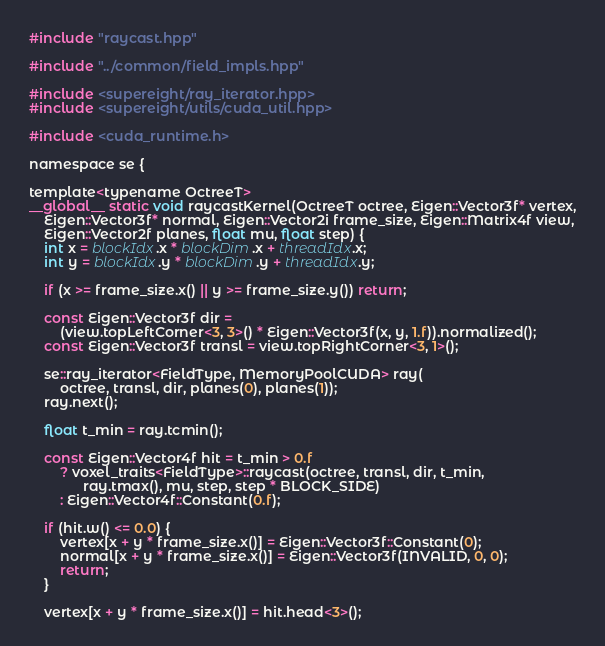Convert code to text. <code><loc_0><loc_0><loc_500><loc_500><_Cuda_>#include "raycast.hpp"

#include "../common/field_impls.hpp"

#include <supereight/ray_iterator.hpp>
#include <supereight/utils/cuda_util.hpp>

#include <cuda_runtime.h>

namespace se {

template<typename OctreeT>
__global__ static void raycastKernel(OctreeT octree, Eigen::Vector3f* vertex,
    Eigen::Vector3f* normal, Eigen::Vector2i frame_size, Eigen::Matrix4f view,
    Eigen::Vector2f planes, float mu, float step) {
    int x = blockIdx.x * blockDim.x + threadIdx.x;
    int y = blockIdx.y * blockDim.y + threadIdx.y;

    if (x >= frame_size.x() || y >= frame_size.y()) return;

    const Eigen::Vector3f dir =
        (view.topLeftCorner<3, 3>() * Eigen::Vector3f(x, y, 1.f)).normalized();
    const Eigen::Vector3f transl = view.topRightCorner<3, 1>();

    se::ray_iterator<FieldType, MemoryPoolCUDA> ray(
        octree, transl, dir, planes(0), planes(1));
    ray.next();

    float t_min = ray.tcmin();

    const Eigen::Vector4f hit = t_min > 0.f
        ? voxel_traits<FieldType>::raycast(octree, transl, dir, t_min,
              ray.tmax(), mu, step, step * BLOCK_SIDE)
        : Eigen::Vector4f::Constant(0.f);

    if (hit.w() <= 0.0) {
        vertex[x + y * frame_size.x()] = Eigen::Vector3f::Constant(0);
        normal[x + y * frame_size.x()] = Eigen::Vector3f(INVALID, 0, 0);
        return;
    }

    vertex[x + y * frame_size.x()] = hit.head<3>();
</code> 